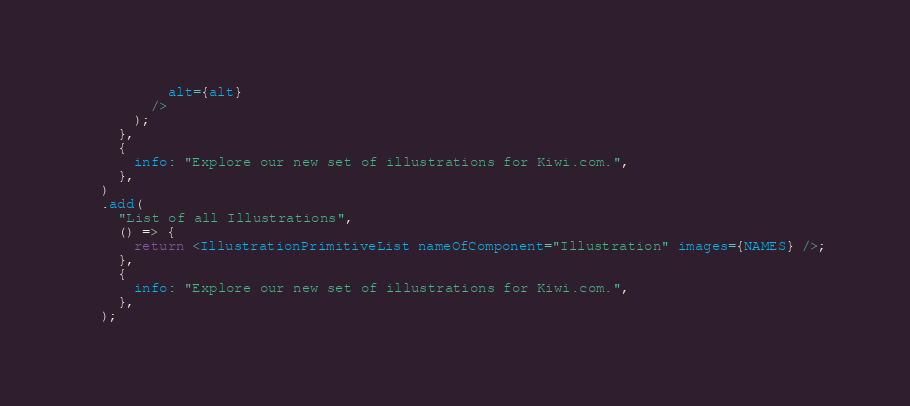Convert code to text. <code><loc_0><loc_0><loc_500><loc_500><_JavaScript_>          alt={alt}
        />
      );
    },
    {
      info: "Explore our new set of illustrations for Kiwi.com.",
    },
  )
  .add(
    "List of all Illustrations",
    () => {
      return <IllustrationPrimitiveList nameOfComponent="Illustration" images={NAMES} />;
    },
    {
      info: "Explore our new set of illustrations for Kiwi.com.",
    },
  );
</code> 